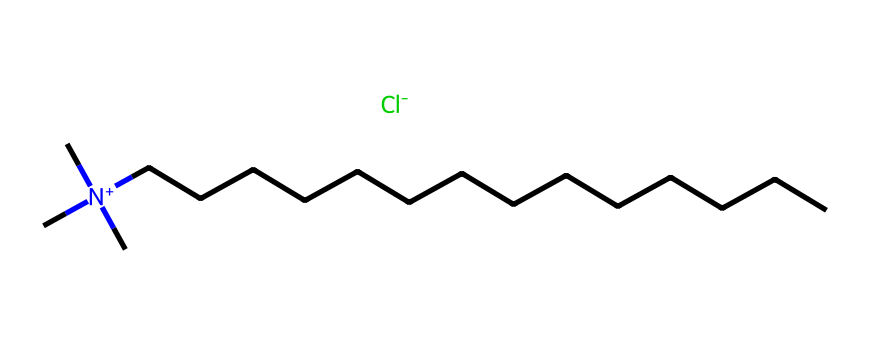What is the total number of carbon atoms in this compound? The SMILES representation indicates a structure with a central nitrogen atom bonded to three methyl groups (as represented by three 'C' symbols) and a long carbon chain consisting of 14 carbon atoms (CCCCCCCCCCCCCC), resulting in a total of 17 carbon atoms.
Answer: 17 How many nitrogen atoms are present in this chemical? The SMILES notation shows a single nitrogen atom present in the structure, as indicated by the 'N+' at the beginning of the representation.
Answer: 1 What is the charge of the nitrogen atom? The representation includes '[N+]', which indicates that the nitrogen atom carries a positive charge. This is confirmed by the presence of three methyl groups and the longer carbon chain, balancing the positive charge with the negatively charged chloride ion '[Cl-]'.
Answer: positive What is the role of the chloride ion in this compound? The chloride ion serves as a counter ion to the positively charged nitrogen. It balances the charge, allowing the compound to remain neutral overall, which is typical for quaternary ammonium compounds used in disinfectants.
Answer: counter ion How many hydrogen atoms are likely associated with this compound? The central nitrogen atom is bonded to three carbons from the methyl groups, which each typically bond to three hydrogens. The long carbon chain has additional hydrogens, but bonding calculations show that a total of 36 hydrogens would likely be attached collectively within the structure.
Answer: 36 What type of chemical classification does this compound belong to? Given its structure, which features a quaternary nitrogen atom with long hydrophobic carbon chains and a positive charge balanced by chloride, this compound classifies as a quaternary ammonium compound, commonly utilized as disinfectants and surfactants.
Answer: quaternary ammonium compound 